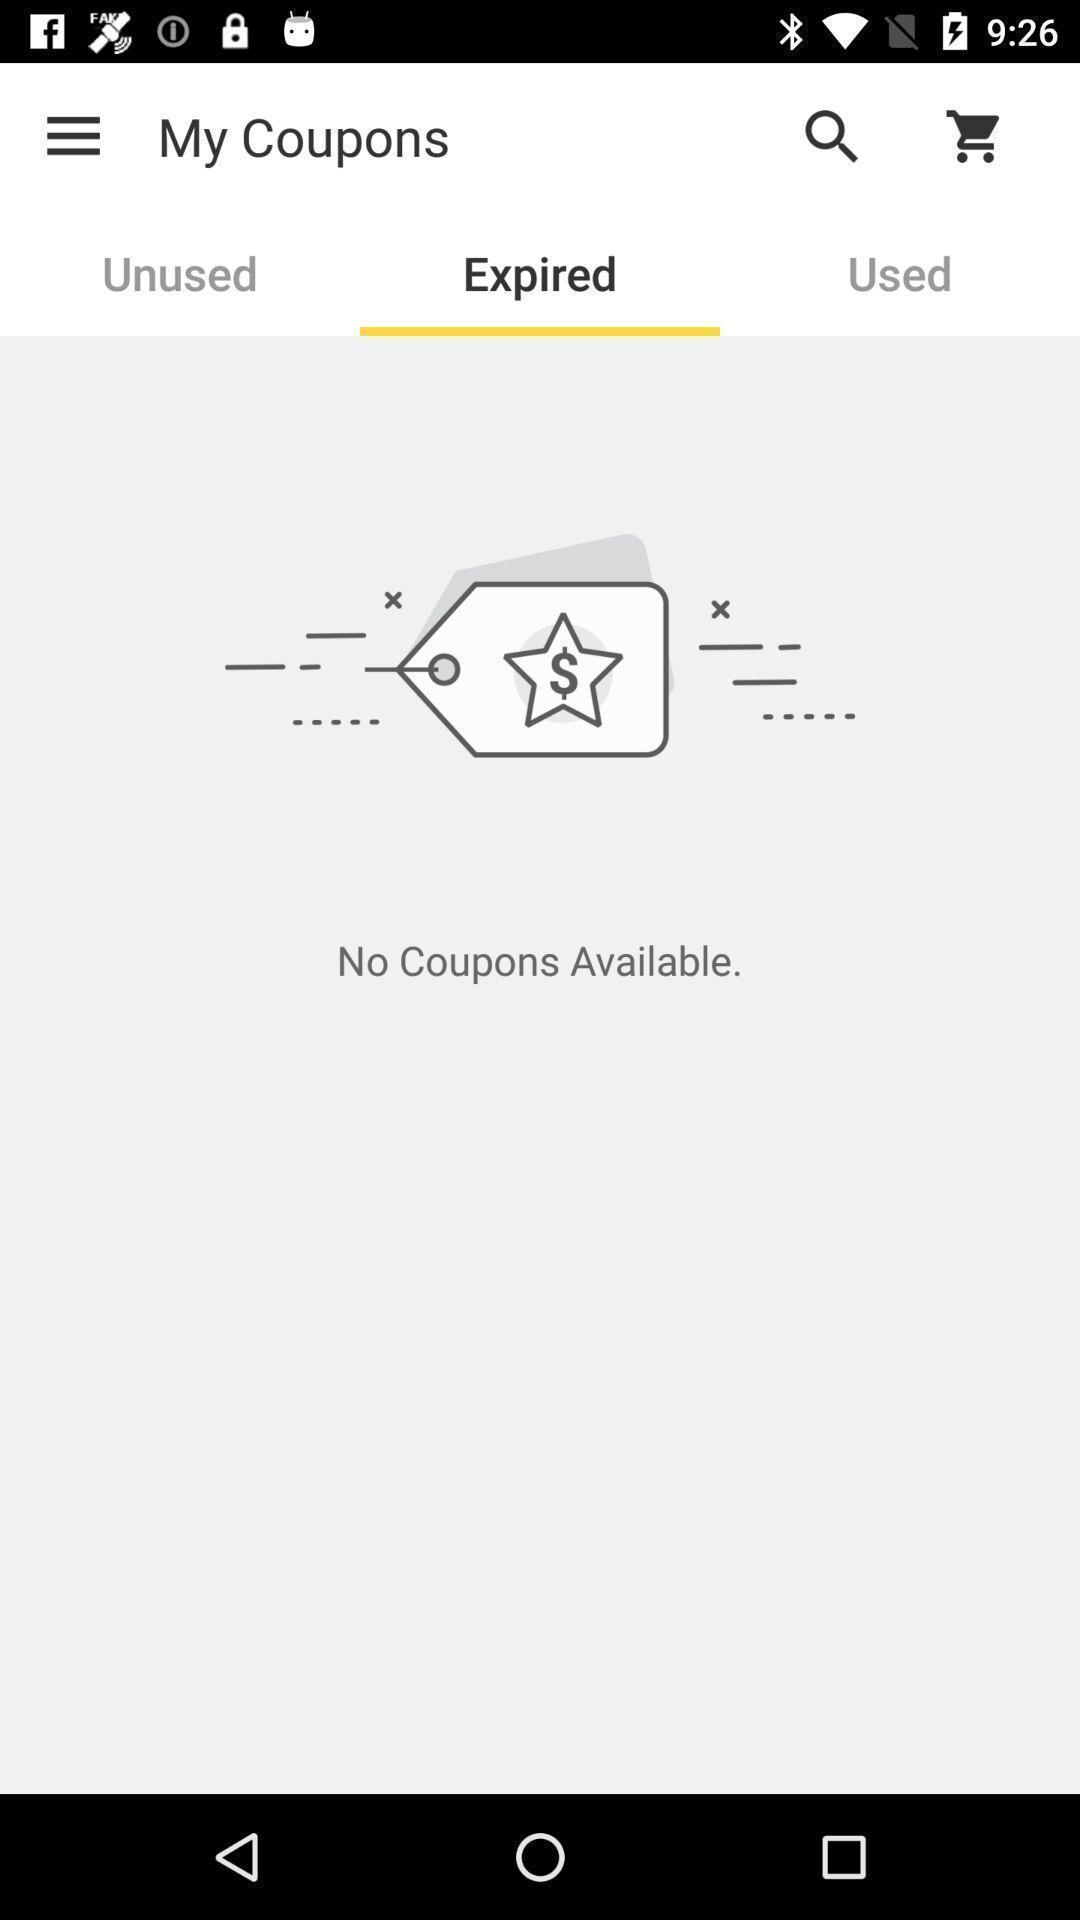What is the overall content of this screenshot? Screen showing no coupons available. 